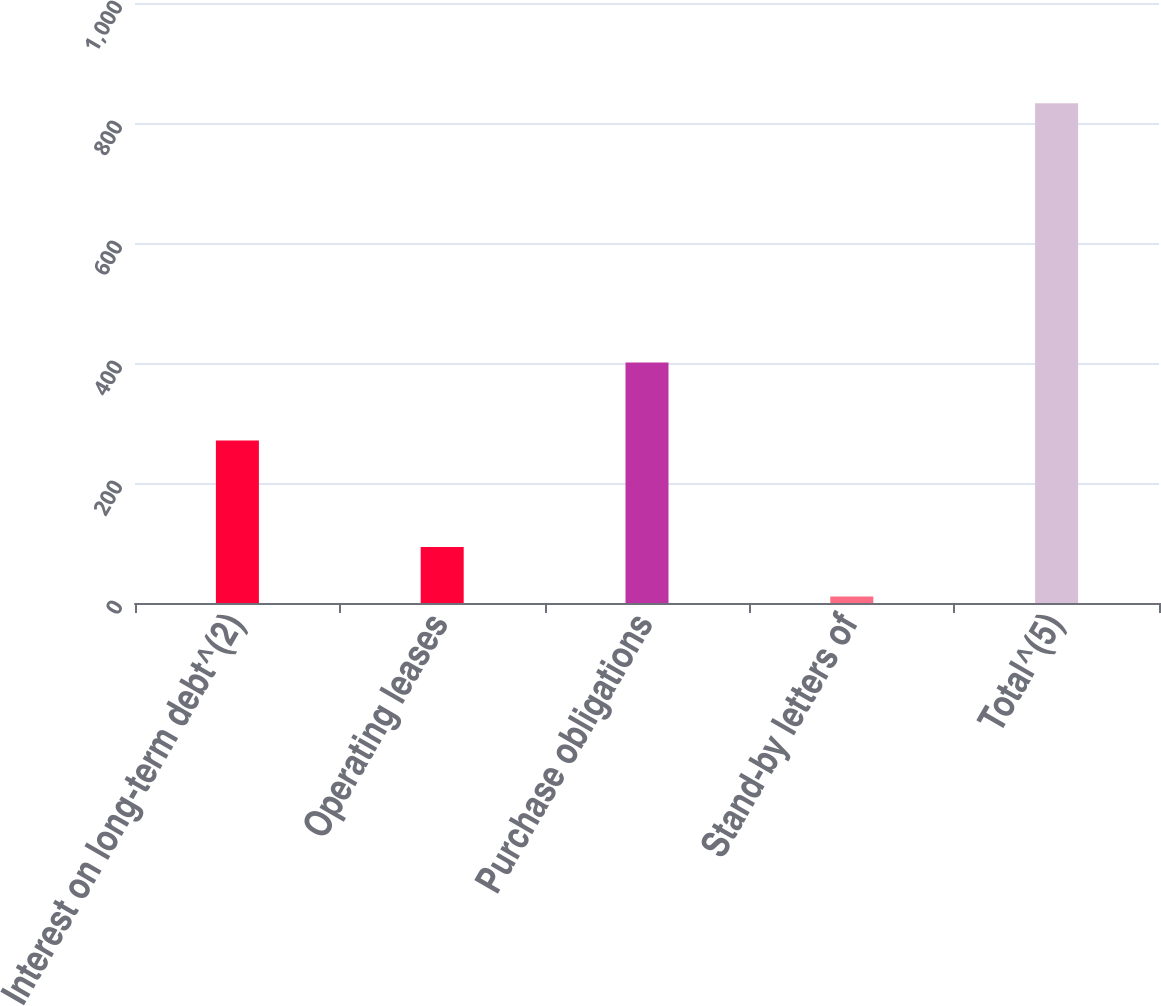Convert chart to OTSL. <chart><loc_0><loc_0><loc_500><loc_500><bar_chart><fcel>Interest on long-term debt^(2)<fcel>Operating leases<fcel>Purchase obligations<fcel>Stand-by letters of<fcel>Total^(5)<nl><fcel>271<fcel>93.2<fcel>401<fcel>11<fcel>833<nl></chart> 